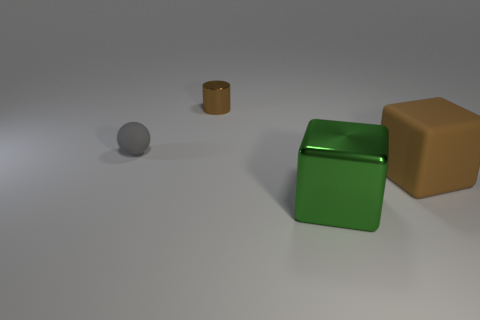What is the shape of the tiny object to the right of the small object that is on the left side of the small shiny thing?
Offer a very short reply. Cylinder. What is the color of the rubber sphere?
Your response must be concise. Gray. How many other objects are the same size as the green object?
Give a very brief answer. 1. What is the material of the thing that is both to the left of the big brown matte cube and on the right side of the brown cylinder?
Your answer should be compact. Metal. There is a rubber object that is on the right side of the gray matte ball; is it the same size as the gray rubber sphere?
Ensure brevity in your answer.  No. Is the color of the large matte object the same as the small metallic thing?
Offer a terse response. Yes. What number of things are both left of the brown rubber cube and in front of the cylinder?
Give a very brief answer. 2. There is a block that is on the left side of the brown object that is in front of the brown cylinder; how many brown things are on the left side of it?
Provide a short and direct response. 1. What size is the metallic object that is the same color as the rubber cube?
Make the answer very short. Small. There is a small rubber object; what shape is it?
Your answer should be compact. Sphere. 